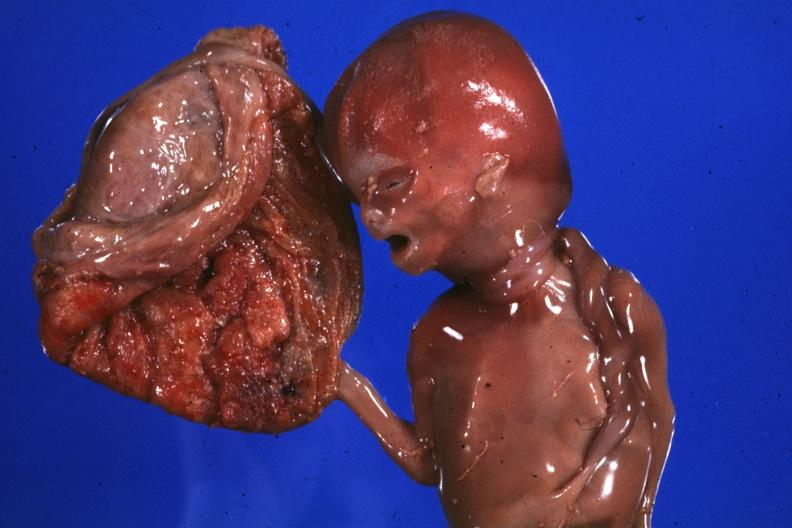how many loops does this image show macerated stillborn with of cord around neck good photo?
Answer the question using a single word or phrase. Two 